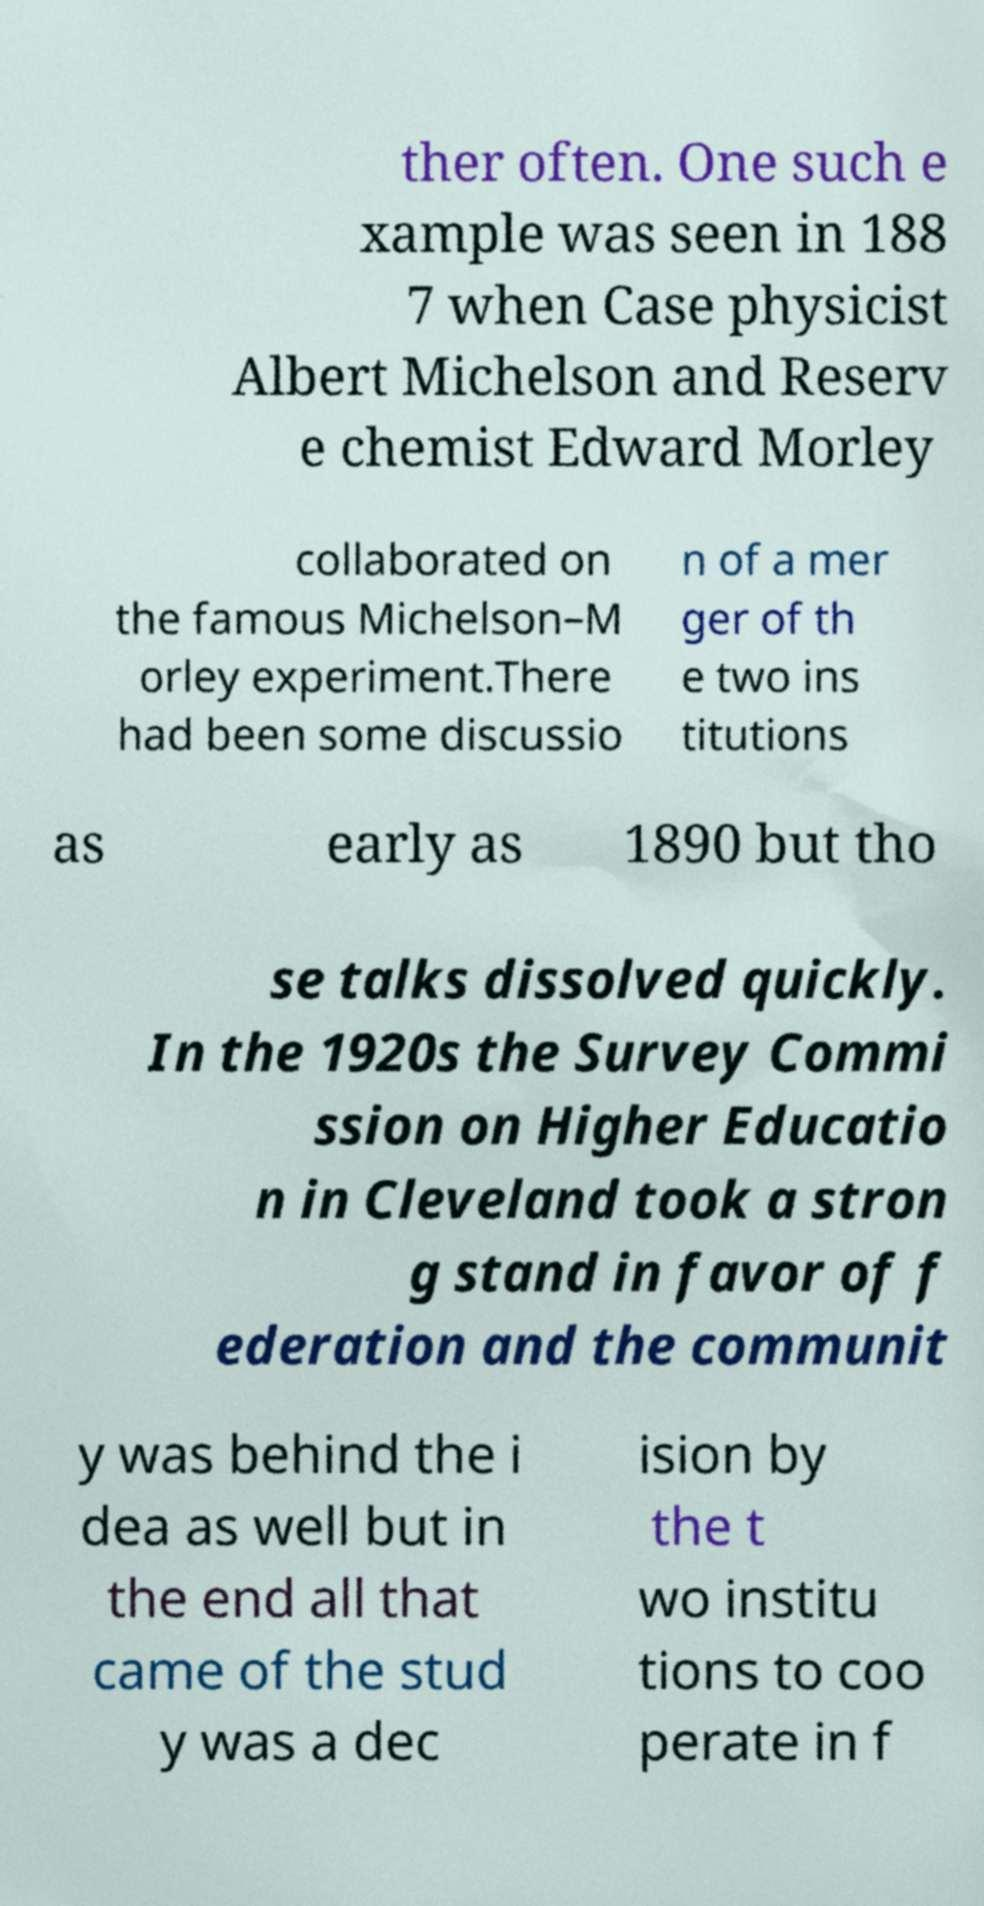For documentation purposes, I need the text within this image transcribed. Could you provide that? ther often. One such e xample was seen in 188 7 when Case physicist Albert Michelson and Reserv e chemist Edward Morley collaborated on the famous Michelson–M orley experiment.There had been some discussio n of a mer ger of th e two ins titutions as early as 1890 but tho se talks dissolved quickly. In the 1920s the Survey Commi ssion on Higher Educatio n in Cleveland took a stron g stand in favor of f ederation and the communit y was behind the i dea as well but in the end all that came of the stud y was a dec ision by the t wo institu tions to coo perate in f 